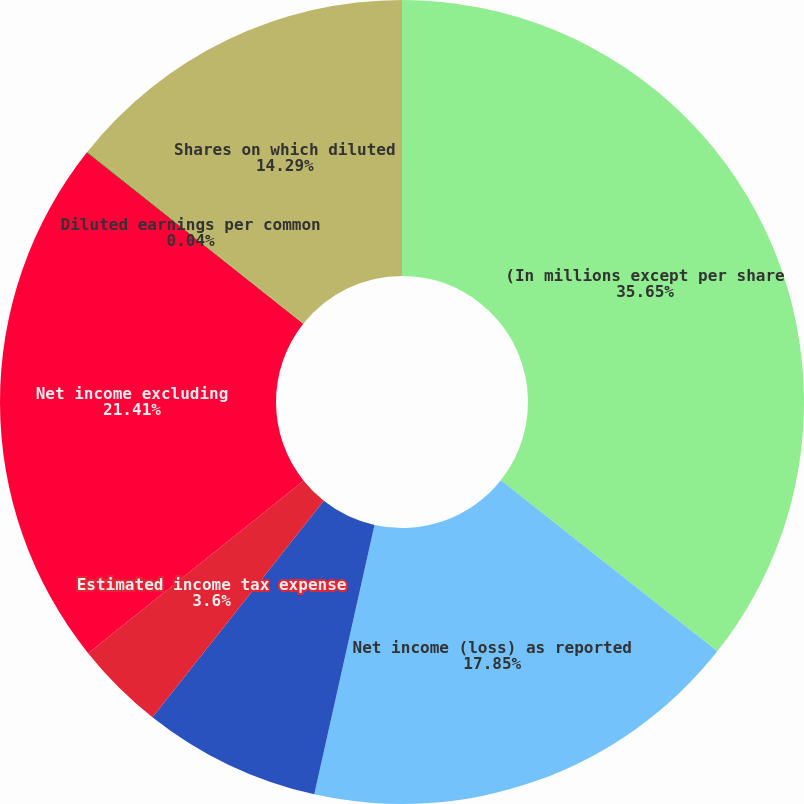Convert chart to OTSL. <chart><loc_0><loc_0><loc_500><loc_500><pie_chart><fcel>(In millions except per share<fcel>Net income (loss) as reported<fcel>Securities Litigation charges<fcel>Estimated income tax expense<fcel>Net income excluding<fcel>Diluted earnings per common<fcel>Shares on which diluted<nl><fcel>35.65%<fcel>17.85%<fcel>7.16%<fcel>3.6%<fcel>21.41%<fcel>0.04%<fcel>14.29%<nl></chart> 